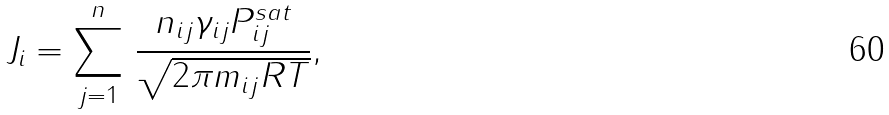<formula> <loc_0><loc_0><loc_500><loc_500>J _ { i } = \sum _ { j = 1 } ^ { n } \, \frac { n _ { i j } \gamma _ { i j } P _ { i j } ^ { s a t } } { \sqrt { 2 \pi m _ { i j } R T } } ,</formula> 